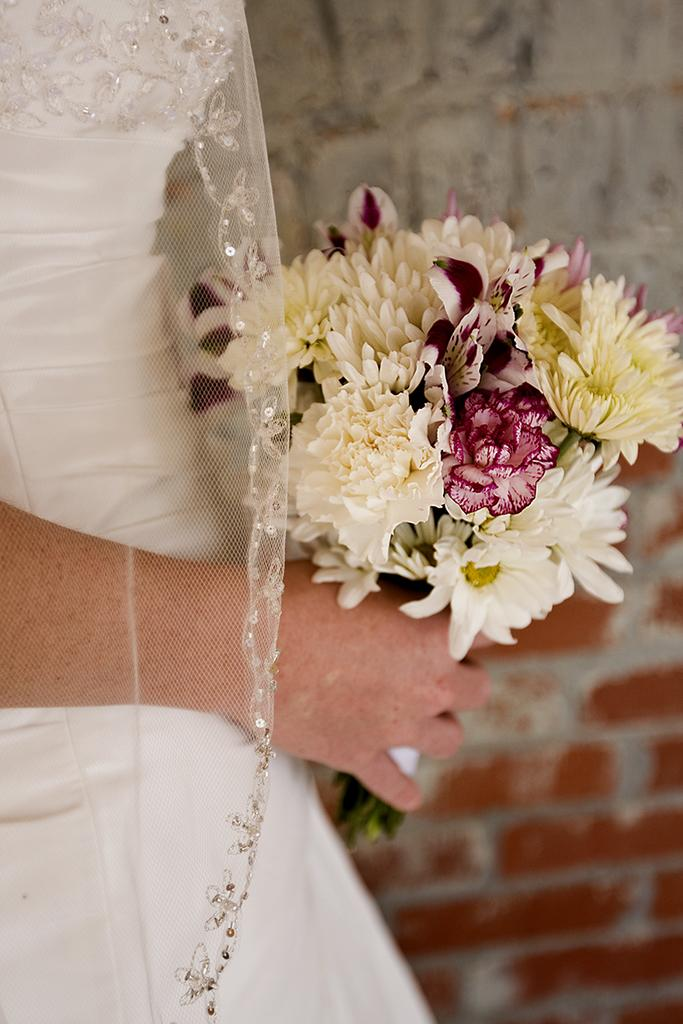What is the main subject of subject of the image? There is a person in the image. What is the person holding in the image? The person is holding a flower bouquet. What can be seen in the background of the image? There is a wall in the background of the image. What type of shoes is the person wearing in the image? There is no information about the person's shoes in the image, so we cannot determine what type they are wearing. 